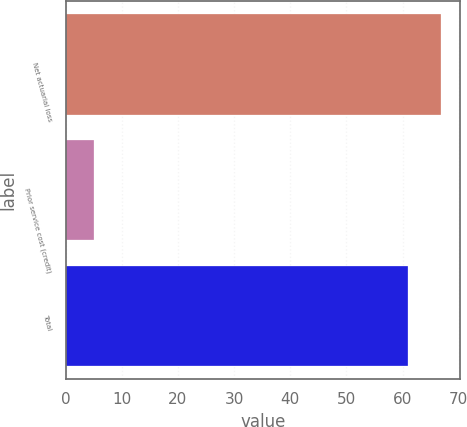Convert chart to OTSL. <chart><loc_0><loc_0><loc_500><loc_500><bar_chart><fcel>Net actuarial loss<fcel>Prior service cost (credit)<fcel>Total<nl><fcel>66.9<fcel>5<fcel>61<nl></chart> 